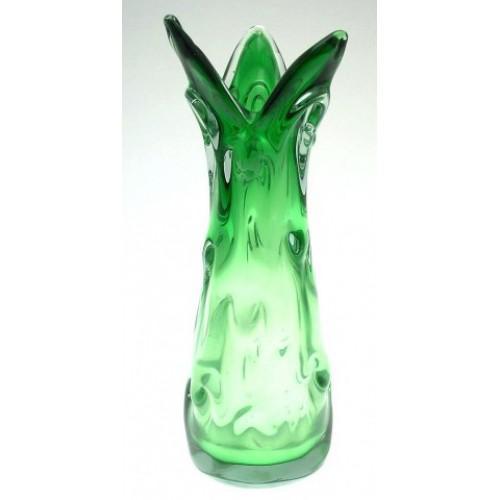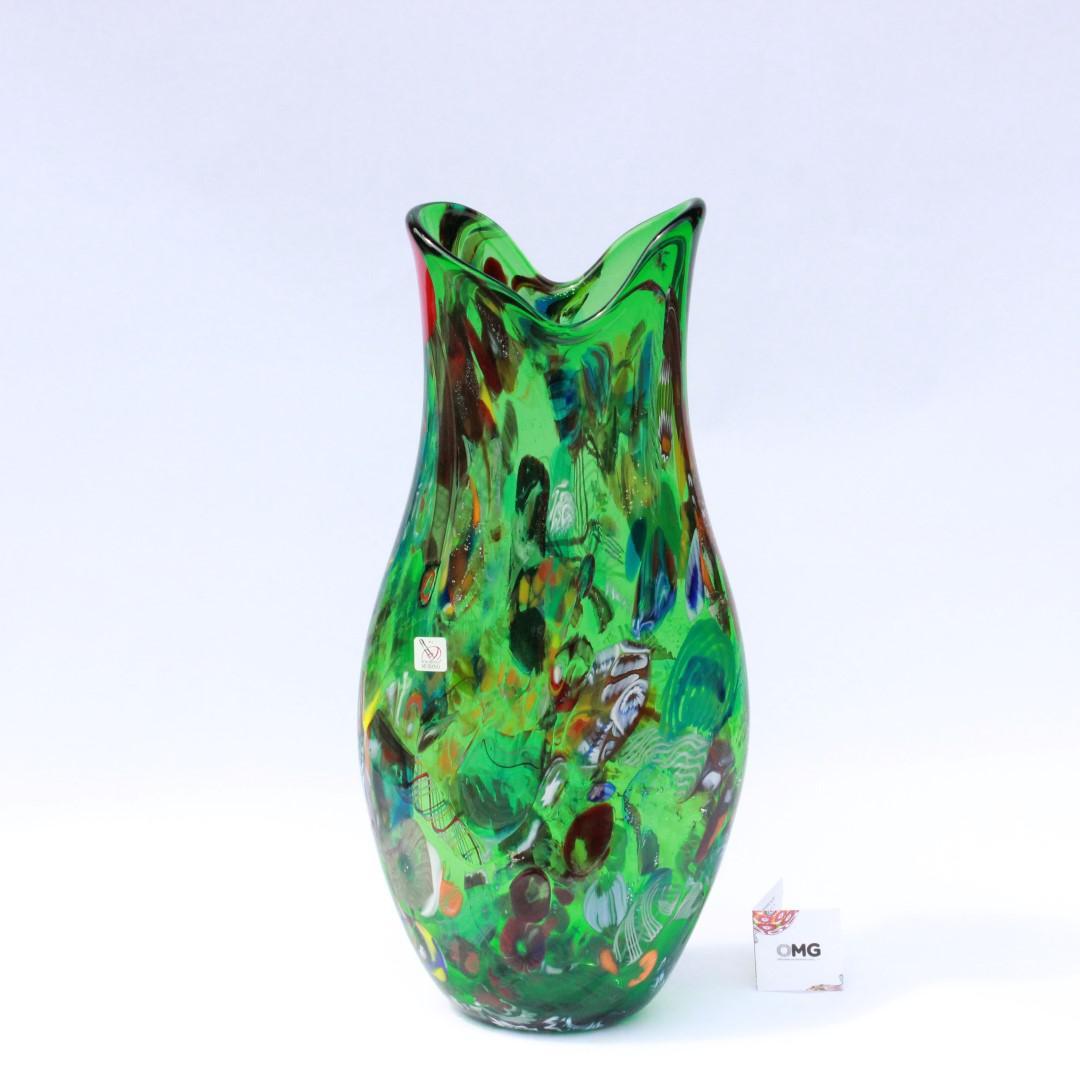The first image is the image on the left, the second image is the image on the right. Evaluate the accuracy of this statement regarding the images: "Each image shows a vase that flares at the top and has colored glass without a regular pattern.". Is it true? Answer yes or no. Yes. The first image is the image on the left, the second image is the image on the right. Evaluate the accuracy of this statement regarding the images: "Both vases are at least party green.". Is it true? Answer yes or no. Yes. 